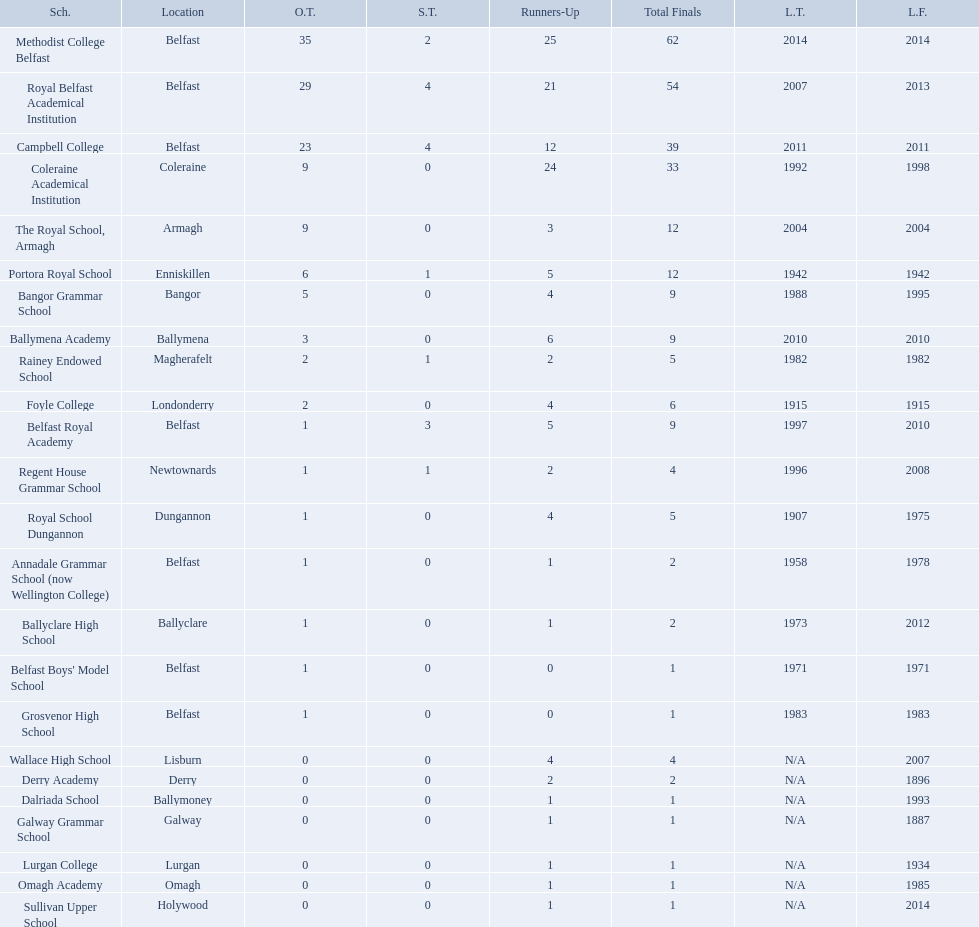What were all of the school names? Methodist College Belfast, Royal Belfast Academical Institution, Campbell College, Coleraine Academical Institution, The Royal School, Armagh, Portora Royal School, Bangor Grammar School, Ballymena Academy, Rainey Endowed School, Foyle College, Belfast Royal Academy, Regent House Grammar School, Royal School Dungannon, Annadale Grammar School (now Wellington College), Ballyclare High School, Belfast Boys' Model School, Grosvenor High School, Wallace High School, Derry Academy, Dalriada School, Galway Grammar School, Lurgan College, Omagh Academy, Sullivan Upper School. How many outright titles did they achieve? 35, 29, 23, 9, 9, 6, 5, 3, 2, 2, 1, 1, 1, 1, 1, 1, 1, 0, 0, 0, 0, 0, 0, 0. And how many did coleraine academical institution receive? 9. Which other school had the same number of outright titles? The Royal School, Armagh. Which colleges participated in the ulster's schools' cup? Methodist College Belfast, Royal Belfast Academical Institution, Campbell College, Coleraine Academical Institution, The Royal School, Armagh, Portora Royal School, Bangor Grammar School, Ballymena Academy, Rainey Endowed School, Foyle College, Belfast Royal Academy, Regent House Grammar School, Royal School Dungannon, Annadale Grammar School (now Wellington College), Ballyclare High School, Belfast Boys' Model School, Grosvenor High School, Wallace High School, Derry Academy, Dalriada School, Galway Grammar School, Lurgan College, Omagh Academy, Sullivan Upper School. Of these, which are from belfast? Methodist College Belfast, Royal Belfast Academical Institution, Campbell College, Belfast Royal Academy, Annadale Grammar School (now Wellington College), Belfast Boys' Model School, Grosvenor High School. Of these, which have more than 20 outright titles? Methodist College Belfast, Royal Belfast Academical Institution, Campbell College. Which of these have the fewest runners-up? Campbell College. 